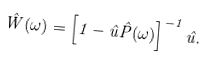<formula> <loc_0><loc_0><loc_500><loc_500>\hat { W } ( \omega ) = \left [ 1 - \hat { u } \hat { P } ( \omega ) \right ] ^ { - 1 } \hat { u } .</formula> 